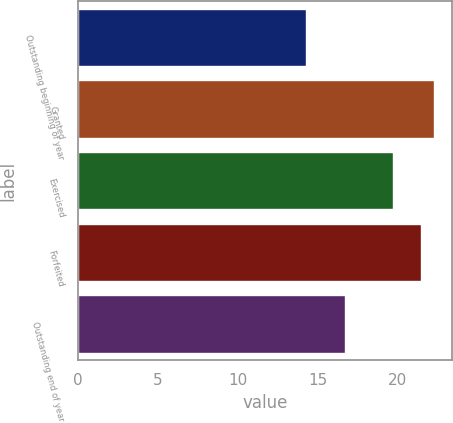Convert chart. <chart><loc_0><loc_0><loc_500><loc_500><bar_chart><fcel>Outstanding beginning of year<fcel>Granted<fcel>Exercised<fcel>Forfeited<fcel>Outstanding end of year<nl><fcel>14.26<fcel>22.32<fcel>19.72<fcel>21.5<fcel>16.7<nl></chart> 